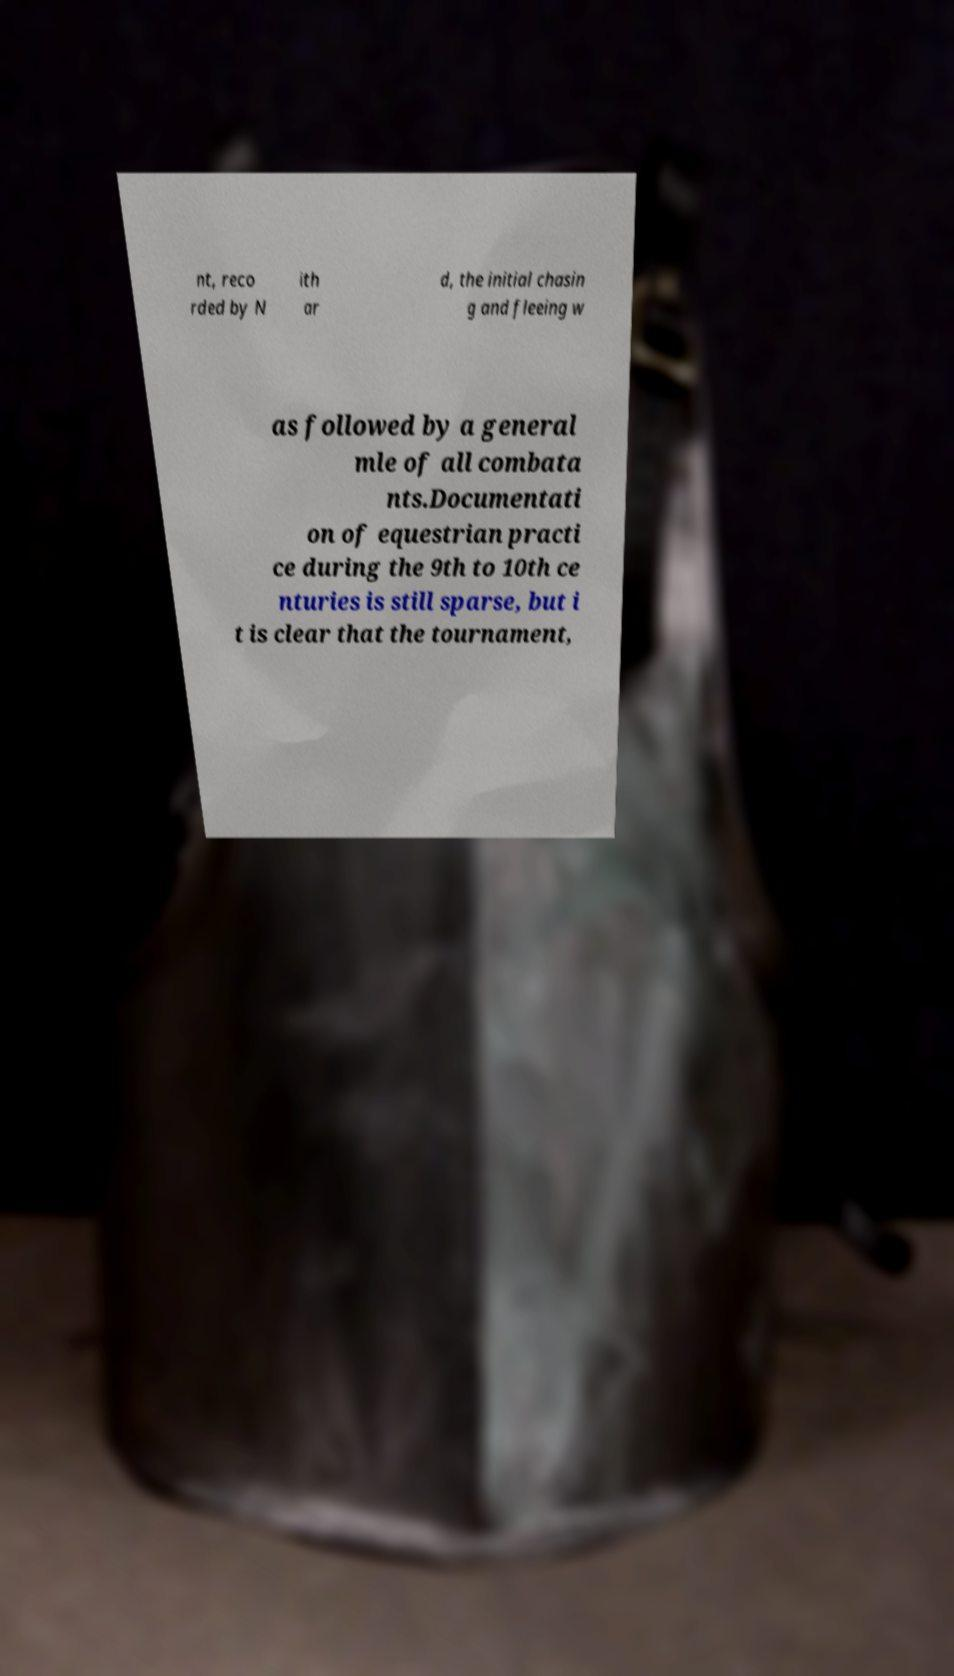Could you assist in decoding the text presented in this image and type it out clearly? nt, reco rded by N ith ar d, the initial chasin g and fleeing w as followed by a general mle of all combata nts.Documentati on of equestrian practi ce during the 9th to 10th ce nturies is still sparse, but i t is clear that the tournament, 